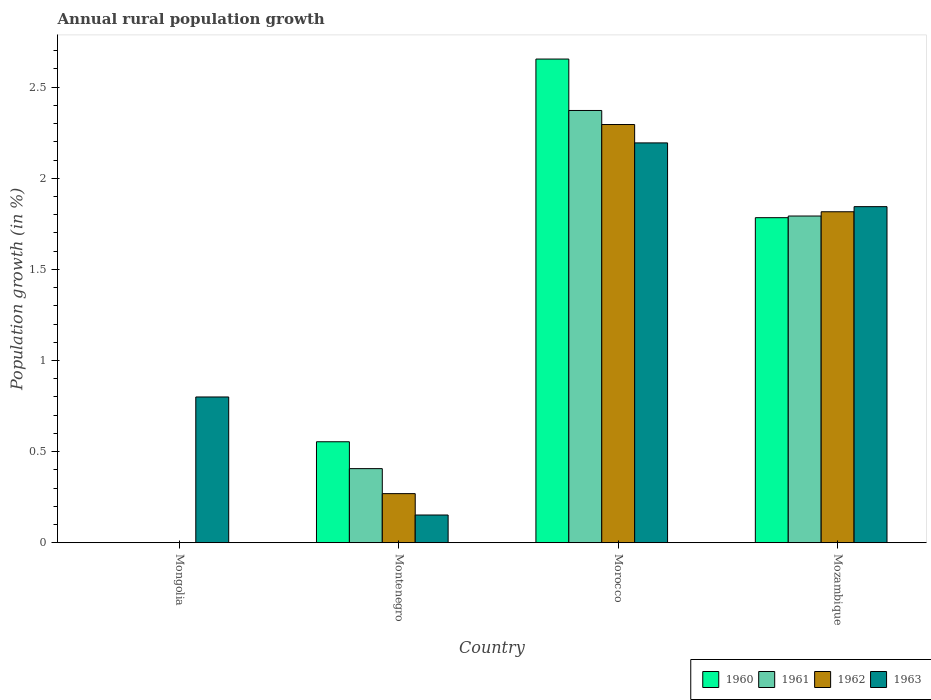What is the label of the 1st group of bars from the left?
Provide a succinct answer. Mongolia. What is the percentage of rural population growth in 1960 in Morocco?
Your answer should be very brief. 2.65. Across all countries, what is the maximum percentage of rural population growth in 1960?
Your answer should be very brief. 2.65. Across all countries, what is the minimum percentage of rural population growth in 1963?
Your answer should be very brief. 0.15. In which country was the percentage of rural population growth in 1962 maximum?
Ensure brevity in your answer.  Morocco. What is the total percentage of rural population growth in 1960 in the graph?
Provide a succinct answer. 4.99. What is the difference between the percentage of rural population growth in 1961 in Morocco and that in Mozambique?
Your answer should be compact. 0.58. What is the difference between the percentage of rural population growth in 1960 in Montenegro and the percentage of rural population growth in 1963 in Mongolia?
Make the answer very short. -0.25. What is the average percentage of rural population growth in 1960 per country?
Make the answer very short. 1.25. What is the difference between the percentage of rural population growth of/in 1961 and percentage of rural population growth of/in 1963 in Mozambique?
Give a very brief answer. -0.05. What is the ratio of the percentage of rural population growth in 1961 in Montenegro to that in Mozambique?
Provide a short and direct response. 0.23. Is the difference between the percentage of rural population growth in 1961 in Montenegro and Morocco greater than the difference between the percentage of rural population growth in 1963 in Montenegro and Morocco?
Make the answer very short. Yes. What is the difference between the highest and the second highest percentage of rural population growth in 1960?
Offer a terse response. -1.23. What is the difference between the highest and the lowest percentage of rural population growth in 1962?
Make the answer very short. 2.3. In how many countries, is the percentage of rural population growth in 1960 greater than the average percentage of rural population growth in 1960 taken over all countries?
Provide a succinct answer. 2. Is the sum of the percentage of rural population growth in 1961 in Montenegro and Morocco greater than the maximum percentage of rural population growth in 1962 across all countries?
Provide a succinct answer. Yes. Is it the case that in every country, the sum of the percentage of rural population growth in 1961 and percentage of rural population growth in 1960 is greater than the sum of percentage of rural population growth in 1962 and percentage of rural population growth in 1963?
Your answer should be very brief. No. Is it the case that in every country, the sum of the percentage of rural population growth in 1960 and percentage of rural population growth in 1961 is greater than the percentage of rural population growth in 1963?
Provide a short and direct response. No. Are all the bars in the graph horizontal?
Ensure brevity in your answer.  No. How many countries are there in the graph?
Ensure brevity in your answer.  4. What is the difference between two consecutive major ticks on the Y-axis?
Provide a succinct answer. 0.5. Are the values on the major ticks of Y-axis written in scientific E-notation?
Ensure brevity in your answer.  No. Does the graph contain any zero values?
Ensure brevity in your answer.  Yes. How many legend labels are there?
Ensure brevity in your answer.  4. How are the legend labels stacked?
Your answer should be very brief. Horizontal. What is the title of the graph?
Offer a terse response. Annual rural population growth. Does "1972" appear as one of the legend labels in the graph?
Your response must be concise. No. What is the label or title of the Y-axis?
Your answer should be compact. Population growth (in %). What is the Population growth (in %) of 1960 in Mongolia?
Give a very brief answer. 0. What is the Population growth (in %) in 1961 in Mongolia?
Make the answer very short. 0. What is the Population growth (in %) in 1963 in Mongolia?
Keep it short and to the point. 0.8. What is the Population growth (in %) in 1960 in Montenegro?
Your response must be concise. 0.55. What is the Population growth (in %) of 1961 in Montenegro?
Offer a very short reply. 0.41. What is the Population growth (in %) of 1962 in Montenegro?
Keep it short and to the point. 0.27. What is the Population growth (in %) of 1963 in Montenegro?
Ensure brevity in your answer.  0.15. What is the Population growth (in %) in 1960 in Morocco?
Your response must be concise. 2.65. What is the Population growth (in %) of 1961 in Morocco?
Your answer should be very brief. 2.37. What is the Population growth (in %) of 1962 in Morocco?
Offer a very short reply. 2.3. What is the Population growth (in %) in 1963 in Morocco?
Your response must be concise. 2.19. What is the Population growth (in %) of 1960 in Mozambique?
Your answer should be compact. 1.78. What is the Population growth (in %) of 1961 in Mozambique?
Make the answer very short. 1.79. What is the Population growth (in %) of 1962 in Mozambique?
Your answer should be compact. 1.82. What is the Population growth (in %) of 1963 in Mozambique?
Ensure brevity in your answer.  1.84. Across all countries, what is the maximum Population growth (in %) of 1960?
Keep it short and to the point. 2.65. Across all countries, what is the maximum Population growth (in %) in 1961?
Your response must be concise. 2.37. Across all countries, what is the maximum Population growth (in %) in 1962?
Ensure brevity in your answer.  2.3. Across all countries, what is the maximum Population growth (in %) in 1963?
Your response must be concise. 2.19. Across all countries, what is the minimum Population growth (in %) in 1962?
Your answer should be compact. 0. Across all countries, what is the minimum Population growth (in %) in 1963?
Provide a succinct answer. 0.15. What is the total Population growth (in %) of 1960 in the graph?
Provide a short and direct response. 4.99. What is the total Population growth (in %) in 1961 in the graph?
Offer a very short reply. 4.57. What is the total Population growth (in %) of 1962 in the graph?
Provide a succinct answer. 4.38. What is the total Population growth (in %) in 1963 in the graph?
Provide a succinct answer. 4.99. What is the difference between the Population growth (in %) in 1963 in Mongolia and that in Montenegro?
Your response must be concise. 0.65. What is the difference between the Population growth (in %) in 1963 in Mongolia and that in Morocco?
Your response must be concise. -1.39. What is the difference between the Population growth (in %) of 1963 in Mongolia and that in Mozambique?
Offer a terse response. -1.04. What is the difference between the Population growth (in %) of 1960 in Montenegro and that in Morocco?
Give a very brief answer. -2.1. What is the difference between the Population growth (in %) of 1961 in Montenegro and that in Morocco?
Ensure brevity in your answer.  -1.97. What is the difference between the Population growth (in %) in 1962 in Montenegro and that in Morocco?
Make the answer very short. -2.03. What is the difference between the Population growth (in %) in 1963 in Montenegro and that in Morocco?
Provide a succinct answer. -2.04. What is the difference between the Population growth (in %) of 1960 in Montenegro and that in Mozambique?
Give a very brief answer. -1.23. What is the difference between the Population growth (in %) of 1961 in Montenegro and that in Mozambique?
Provide a short and direct response. -1.39. What is the difference between the Population growth (in %) of 1962 in Montenegro and that in Mozambique?
Make the answer very short. -1.55. What is the difference between the Population growth (in %) of 1963 in Montenegro and that in Mozambique?
Offer a terse response. -1.69. What is the difference between the Population growth (in %) in 1960 in Morocco and that in Mozambique?
Offer a terse response. 0.87. What is the difference between the Population growth (in %) of 1961 in Morocco and that in Mozambique?
Your response must be concise. 0.58. What is the difference between the Population growth (in %) of 1962 in Morocco and that in Mozambique?
Ensure brevity in your answer.  0.48. What is the difference between the Population growth (in %) of 1963 in Morocco and that in Mozambique?
Make the answer very short. 0.35. What is the difference between the Population growth (in %) in 1960 in Montenegro and the Population growth (in %) in 1961 in Morocco?
Offer a terse response. -1.82. What is the difference between the Population growth (in %) of 1960 in Montenegro and the Population growth (in %) of 1962 in Morocco?
Offer a terse response. -1.74. What is the difference between the Population growth (in %) of 1960 in Montenegro and the Population growth (in %) of 1963 in Morocco?
Make the answer very short. -1.64. What is the difference between the Population growth (in %) of 1961 in Montenegro and the Population growth (in %) of 1962 in Morocco?
Your answer should be very brief. -1.89. What is the difference between the Population growth (in %) in 1961 in Montenegro and the Population growth (in %) in 1963 in Morocco?
Your answer should be very brief. -1.79. What is the difference between the Population growth (in %) in 1962 in Montenegro and the Population growth (in %) in 1963 in Morocco?
Your response must be concise. -1.93. What is the difference between the Population growth (in %) of 1960 in Montenegro and the Population growth (in %) of 1961 in Mozambique?
Your answer should be compact. -1.24. What is the difference between the Population growth (in %) of 1960 in Montenegro and the Population growth (in %) of 1962 in Mozambique?
Your response must be concise. -1.26. What is the difference between the Population growth (in %) of 1960 in Montenegro and the Population growth (in %) of 1963 in Mozambique?
Provide a short and direct response. -1.29. What is the difference between the Population growth (in %) in 1961 in Montenegro and the Population growth (in %) in 1962 in Mozambique?
Make the answer very short. -1.41. What is the difference between the Population growth (in %) in 1961 in Montenegro and the Population growth (in %) in 1963 in Mozambique?
Your response must be concise. -1.44. What is the difference between the Population growth (in %) in 1962 in Montenegro and the Population growth (in %) in 1963 in Mozambique?
Offer a very short reply. -1.58. What is the difference between the Population growth (in %) of 1960 in Morocco and the Population growth (in %) of 1961 in Mozambique?
Give a very brief answer. 0.86. What is the difference between the Population growth (in %) in 1960 in Morocco and the Population growth (in %) in 1962 in Mozambique?
Your answer should be very brief. 0.84. What is the difference between the Population growth (in %) of 1960 in Morocco and the Population growth (in %) of 1963 in Mozambique?
Your answer should be compact. 0.81. What is the difference between the Population growth (in %) in 1961 in Morocco and the Population growth (in %) in 1962 in Mozambique?
Give a very brief answer. 0.56. What is the difference between the Population growth (in %) of 1961 in Morocco and the Population growth (in %) of 1963 in Mozambique?
Provide a short and direct response. 0.53. What is the difference between the Population growth (in %) in 1962 in Morocco and the Population growth (in %) in 1963 in Mozambique?
Offer a terse response. 0.45. What is the average Population growth (in %) of 1960 per country?
Make the answer very short. 1.25. What is the average Population growth (in %) in 1961 per country?
Provide a short and direct response. 1.14. What is the average Population growth (in %) of 1962 per country?
Give a very brief answer. 1.1. What is the average Population growth (in %) of 1963 per country?
Provide a succinct answer. 1.25. What is the difference between the Population growth (in %) of 1960 and Population growth (in %) of 1961 in Montenegro?
Offer a terse response. 0.15. What is the difference between the Population growth (in %) of 1960 and Population growth (in %) of 1962 in Montenegro?
Offer a very short reply. 0.28. What is the difference between the Population growth (in %) in 1960 and Population growth (in %) in 1963 in Montenegro?
Keep it short and to the point. 0.4. What is the difference between the Population growth (in %) of 1961 and Population growth (in %) of 1962 in Montenegro?
Provide a succinct answer. 0.14. What is the difference between the Population growth (in %) of 1961 and Population growth (in %) of 1963 in Montenegro?
Offer a very short reply. 0.25. What is the difference between the Population growth (in %) of 1962 and Population growth (in %) of 1963 in Montenegro?
Your response must be concise. 0.12. What is the difference between the Population growth (in %) of 1960 and Population growth (in %) of 1961 in Morocco?
Your response must be concise. 0.28. What is the difference between the Population growth (in %) of 1960 and Population growth (in %) of 1962 in Morocco?
Provide a short and direct response. 0.36. What is the difference between the Population growth (in %) in 1960 and Population growth (in %) in 1963 in Morocco?
Your answer should be compact. 0.46. What is the difference between the Population growth (in %) in 1961 and Population growth (in %) in 1962 in Morocco?
Give a very brief answer. 0.08. What is the difference between the Population growth (in %) in 1961 and Population growth (in %) in 1963 in Morocco?
Provide a succinct answer. 0.18. What is the difference between the Population growth (in %) of 1962 and Population growth (in %) of 1963 in Morocco?
Keep it short and to the point. 0.1. What is the difference between the Population growth (in %) in 1960 and Population growth (in %) in 1961 in Mozambique?
Provide a succinct answer. -0.01. What is the difference between the Population growth (in %) of 1960 and Population growth (in %) of 1962 in Mozambique?
Offer a very short reply. -0.03. What is the difference between the Population growth (in %) of 1960 and Population growth (in %) of 1963 in Mozambique?
Provide a short and direct response. -0.06. What is the difference between the Population growth (in %) in 1961 and Population growth (in %) in 1962 in Mozambique?
Provide a succinct answer. -0.02. What is the difference between the Population growth (in %) of 1961 and Population growth (in %) of 1963 in Mozambique?
Your answer should be very brief. -0.05. What is the difference between the Population growth (in %) of 1962 and Population growth (in %) of 1963 in Mozambique?
Offer a terse response. -0.03. What is the ratio of the Population growth (in %) of 1963 in Mongolia to that in Montenegro?
Your answer should be very brief. 5.26. What is the ratio of the Population growth (in %) in 1963 in Mongolia to that in Morocco?
Offer a terse response. 0.36. What is the ratio of the Population growth (in %) in 1963 in Mongolia to that in Mozambique?
Give a very brief answer. 0.43. What is the ratio of the Population growth (in %) in 1960 in Montenegro to that in Morocco?
Provide a succinct answer. 0.21. What is the ratio of the Population growth (in %) in 1961 in Montenegro to that in Morocco?
Provide a short and direct response. 0.17. What is the ratio of the Population growth (in %) of 1962 in Montenegro to that in Morocco?
Your answer should be very brief. 0.12. What is the ratio of the Population growth (in %) in 1963 in Montenegro to that in Morocco?
Offer a very short reply. 0.07. What is the ratio of the Population growth (in %) in 1960 in Montenegro to that in Mozambique?
Your answer should be compact. 0.31. What is the ratio of the Population growth (in %) of 1961 in Montenegro to that in Mozambique?
Provide a succinct answer. 0.23. What is the ratio of the Population growth (in %) of 1962 in Montenegro to that in Mozambique?
Your answer should be compact. 0.15. What is the ratio of the Population growth (in %) of 1963 in Montenegro to that in Mozambique?
Your response must be concise. 0.08. What is the ratio of the Population growth (in %) of 1960 in Morocco to that in Mozambique?
Your answer should be compact. 1.49. What is the ratio of the Population growth (in %) of 1961 in Morocco to that in Mozambique?
Offer a very short reply. 1.32. What is the ratio of the Population growth (in %) of 1962 in Morocco to that in Mozambique?
Your answer should be very brief. 1.26. What is the ratio of the Population growth (in %) in 1963 in Morocco to that in Mozambique?
Your answer should be compact. 1.19. What is the difference between the highest and the second highest Population growth (in %) in 1960?
Your answer should be very brief. 0.87. What is the difference between the highest and the second highest Population growth (in %) in 1961?
Offer a very short reply. 0.58. What is the difference between the highest and the second highest Population growth (in %) of 1962?
Give a very brief answer. 0.48. What is the difference between the highest and the second highest Population growth (in %) of 1963?
Your answer should be very brief. 0.35. What is the difference between the highest and the lowest Population growth (in %) of 1960?
Make the answer very short. 2.65. What is the difference between the highest and the lowest Population growth (in %) in 1961?
Offer a terse response. 2.37. What is the difference between the highest and the lowest Population growth (in %) of 1962?
Offer a very short reply. 2.3. What is the difference between the highest and the lowest Population growth (in %) in 1963?
Make the answer very short. 2.04. 